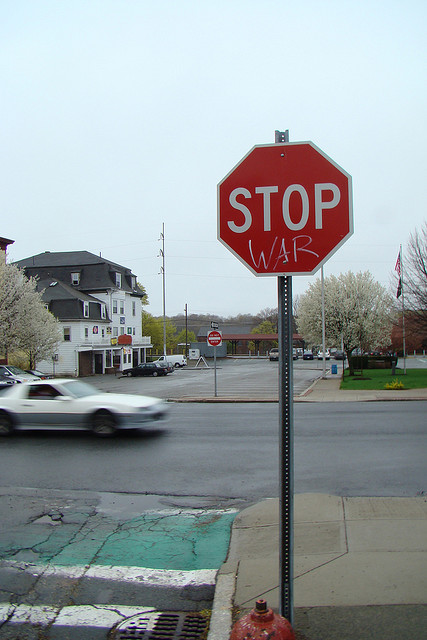How many different colors were used for all the graffiti? The image you're asking about doesn't actually contain any graffiti. Instead, it shows a modified stop sign that reads 'STOP WAR' in white letters on a red background. Since we're looking at a standard stop sign with an added anti-war message, there's only one color used for the text alteration, which is white. 